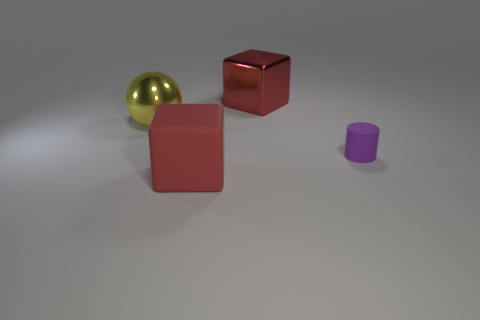Is there anything else of the same color as the big shiny cube?
Your answer should be compact. Yes. There is a metallic object right of the big yellow shiny object; does it have the same color as the rubber block?
Provide a short and direct response. Yes. The other big object that is the same shape as the red shiny object is what color?
Make the answer very short. Red. What number of things are red cubes that are behind the small thing or big metallic objects to the right of the rubber cube?
Offer a very short reply. 1. What is the shape of the yellow metallic thing?
Give a very brief answer. Sphere. What is the shape of the big shiny object that is the same color as the big rubber thing?
Offer a very short reply. Cube. What number of cubes have the same material as the ball?
Offer a terse response. 1. The big ball is what color?
Give a very brief answer. Yellow. What color is the metal ball that is the same size as the red rubber cube?
Offer a very short reply. Yellow. Is there a large object that has the same color as the large metallic block?
Offer a very short reply. Yes. 